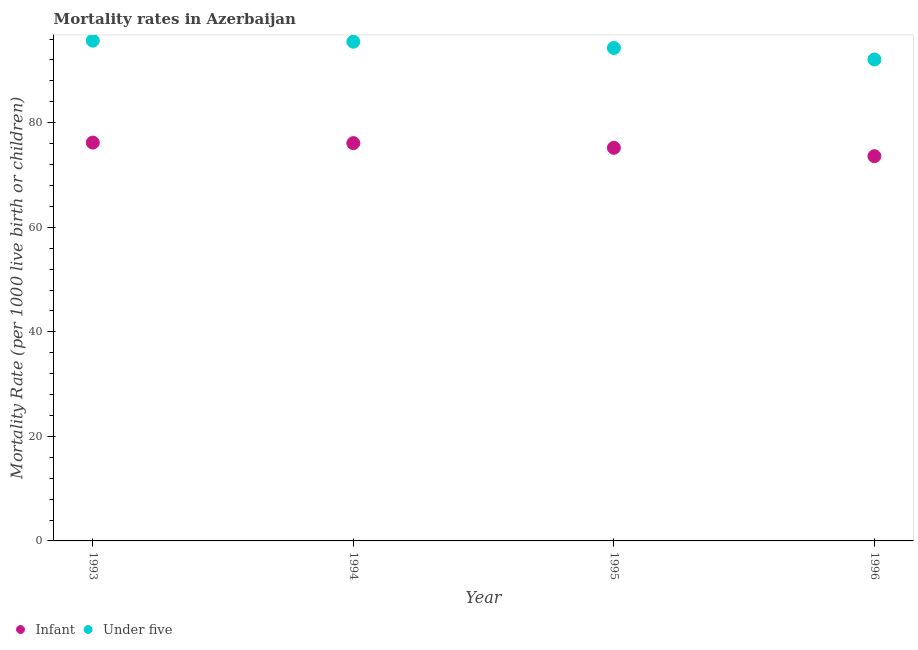Is the number of dotlines equal to the number of legend labels?
Provide a short and direct response. Yes. What is the infant mortality rate in 1995?
Offer a very short reply. 75.2. Across all years, what is the maximum infant mortality rate?
Give a very brief answer. 76.2. Across all years, what is the minimum infant mortality rate?
Your answer should be compact. 73.6. In which year was the under-5 mortality rate maximum?
Your answer should be very brief. 1993. In which year was the under-5 mortality rate minimum?
Keep it short and to the point. 1996. What is the total infant mortality rate in the graph?
Provide a short and direct response. 301.1. What is the difference between the infant mortality rate in 1995 and that in 1996?
Give a very brief answer. 1.6. What is the difference between the infant mortality rate in 1994 and the under-5 mortality rate in 1995?
Provide a succinct answer. -18.2. What is the average under-5 mortality rate per year?
Your response must be concise. 94.4. In the year 1994, what is the difference between the infant mortality rate and under-5 mortality rate?
Provide a short and direct response. -19.4. What is the ratio of the infant mortality rate in 1993 to that in 1996?
Ensure brevity in your answer.  1.04. Is the infant mortality rate in 1993 less than that in 1994?
Make the answer very short. No. Is the difference between the infant mortality rate in 1993 and 1995 greater than the difference between the under-5 mortality rate in 1993 and 1995?
Provide a succinct answer. No. What is the difference between the highest and the second highest infant mortality rate?
Give a very brief answer. 0.1. What is the difference between the highest and the lowest infant mortality rate?
Your response must be concise. 2.6. Is the sum of the infant mortality rate in 1994 and 1995 greater than the maximum under-5 mortality rate across all years?
Provide a succinct answer. Yes. Is the infant mortality rate strictly less than the under-5 mortality rate over the years?
Offer a very short reply. Yes. How many dotlines are there?
Keep it short and to the point. 2. How many years are there in the graph?
Make the answer very short. 4. Does the graph contain any zero values?
Make the answer very short. No. What is the title of the graph?
Offer a terse response. Mortality rates in Azerbaijan. Does "Urban Population" appear as one of the legend labels in the graph?
Offer a very short reply. No. What is the label or title of the Y-axis?
Give a very brief answer. Mortality Rate (per 1000 live birth or children). What is the Mortality Rate (per 1000 live birth or children) of Infant in 1993?
Your response must be concise. 76.2. What is the Mortality Rate (per 1000 live birth or children) of Under five in 1993?
Offer a terse response. 95.7. What is the Mortality Rate (per 1000 live birth or children) in Infant in 1994?
Give a very brief answer. 76.1. What is the Mortality Rate (per 1000 live birth or children) of Under five in 1994?
Your answer should be compact. 95.5. What is the Mortality Rate (per 1000 live birth or children) of Infant in 1995?
Provide a short and direct response. 75.2. What is the Mortality Rate (per 1000 live birth or children) of Under five in 1995?
Offer a very short reply. 94.3. What is the Mortality Rate (per 1000 live birth or children) of Infant in 1996?
Make the answer very short. 73.6. What is the Mortality Rate (per 1000 live birth or children) of Under five in 1996?
Give a very brief answer. 92.1. Across all years, what is the maximum Mortality Rate (per 1000 live birth or children) of Infant?
Ensure brevity in your answer.  76.2. Across all years, what is the maximum Mortality Rate (per 1000 live birth or children) in Under five?
Give a very brief answer. 95.7. Across all years, what is the minimum Mortality Rate (per 1000 live birth or children) of Infant?
Your response must be concise. 73.6. Across all years, what is the minimum Mortality Rate (per 1000 live birth or children) in Under five?
Your answer should be compact. 92.1. What is the total Mortality Rate (per 1000 live birth or children) of Infant in the graph?
Keep it short and to the point. 301.1. What is the total Mortality Rate (per 1000 live birth or children) of Under five in the graph?
Provide a short and direct response. 377.6. What is the difference between the Mortality Rate (per 1000 live birth or children) of Under five in 1993 and that in 1994?
Keep it short and to the point. 0.2. What is the difference between the Mortality Rate (per 1000 live birth or children) in Infant in 1993 and that in 1995?
Offer a very short reply. 1. What is the difference between the Mortality Rate (per 1000 live birth or children) of Under five in 1993 and that in 1995?
Your response must be concise. 1.4. What is the difference between the Mortality Rate (per 1000 live birth or children) in Infant in 1993 and that in 1996?
Ensure brevity in your answer.  2.6. What is the difference between the Mortality Rate (per 1000 live birth or children) of Infant in 1994 and that in 1996?
Your answer should be very brief. 2.5. What is the difference between the Mortality Rate (per 1000 live birth or children) in Under five in 1994 and that in 1996?
Make the answer very short. 3.4. What is the difference between the Mortality Rate (per 1000 live birth or children) of Infant in 1993 and the Mortality Rate (per 1000 live birth or children) of Under five in 1994?
Offer a terse response. -19.3. What is the difference between the Mortality Rate (per 1000 live birth or children) of Infant in 1993 and the Mortality Rate (per 1000 live birth or children) of Under five in 1995?
Your answer should be compact. -18.1. What is the difference between the Mortality Rate (per 1000 live birth or children) in Infant in 1993 and the Mortality Rate (per 1000 live birth or children) in Under five in 1996?
Ensure brevity in your answer.  -15.9. What is the difference between the Mortality Rate (per 1000 live birth or children) of Infant in 1994 and the Mortality Rate (per 1000 live birth or children) of Under five in 1995?
Make the answer very short. -18.2. What is the difference between the Mortality Rate (per 1000 live birth or children) of Infant in 1995 and the Mortality Rate (per 1000 live birth or children) of Under five in 1996?
Provide a succinct answer. -16.9. What is the average Mortality Rate (per 1000 live birth or children) of Infant per year?
Your answer should be compact. 75.28. What is the average Mortality Rate (per 1000 live birth or children) in Under five per year?
Your answer should be very brief. 94.4. In the year 1993, what is the difference between the Mortality Rate (per 1000 live birth or children) in Infant and Mortality Rate (per 1000 live birth or children) in Under five?
Your answer should be compact. -19.5. In the year 1994, what is the difference between the Mortality Rate (per 1000 live birth or children) of Infant and Mortality Rate (per 1000 live birth or children) of Under five?
Offer a very short reply. -19.4. In the year 1995, what is the difference between the Mortality Rate (per 1000 live birth or children) in Infant and Mortality Rate (per 1000 live birth or children) in Under five?
Give a very brief answer. -19.1. In the year 1996, what is the difference between the Mortality Rate (per 1000 live birth or children) in Infant and Mortality Rate (per 1000 live birth or children) in Under five?
Make the answer very short. -18.5. What is the ratio of the Mortality Rate (per 1000 live birth or children) of Infant in 1993 to that in 1994?
Give a very brief answer. 1. What is the ratio of the Mortality Rate (per 1000 live birth or children) in Infant in 1993 to that in 1995?
Offer a terse response. 1.01. What is the ratio of the Mortality Rate (per 1000 live birth or children) of Under five in 1993 to that in 1995?
Provide a succinct answer. 1.01. What is the ratio of the Mortality Rate (per 1000 live birth or children) of Infant in 1993 to that in 1996?
Keep it short and to the point. 1.04. What is the ratio of the Mortality Rate (per 1000 live birth or children) in Under five in 1993 to that in 1996?
Keep it short and to the point. 1.04. What is the ratio of the Mortality Rate (per 1000 live birth or children) in Under five in 1994 to that in 1995?
Your response must be concise. 1.01. What is the ratio of the Mortality Rate (per 1000 live birth or children) in Infant in 1994 to that in 1996?
Offer a very short reply. 1.03. What is the ratio of the Mortality Rate (per 1000 live birth or children) of Under five in 1994 to that in 1996?
Provide a succinct answer. 1.04. What is the ratio of the Mortality Rate (per 1000 live birth or children) of Infant in 1995 to that in 1996?
Give a very brief answer. 1.02. What is the ratio of the Mortality Rate (per 1000 live birth or children) in Under five in 1995 to that in 1996?
Offer a very short reply. 1.02. What is the difference between the highest and the second highest Mortality Rate (per 1000 live birth or children) of Under five?
Your response must be concise. 0.2. What is the difference between the highest and the lowest Mortality Rate (per 1000 live birth or children) of Infant?
Your response must be concise. 2.6. 